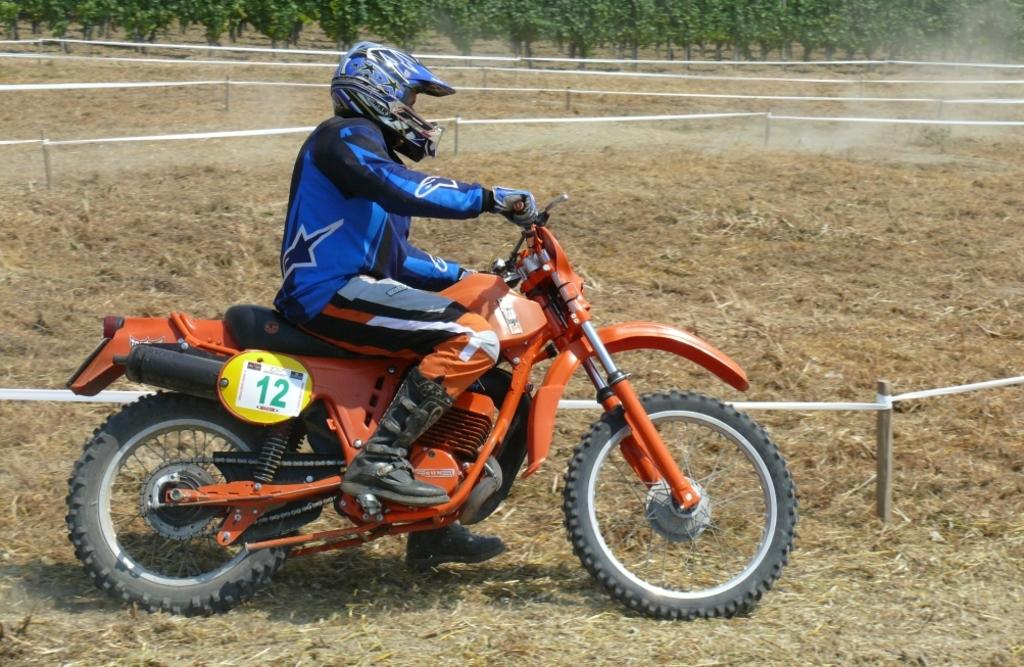What is the main subject of the image? There is a man in the image. What is the man doing in the image? The man is riding a sports bike. What color is the sports bike? The sports bike is orange in color. What is the man wearing while riding the sports bike? The man is wearing a blue dress and a helmet. What can be seen in the background of the image? There are trees visible at the top of the image. What type of ball is the man holding while riding the sports bike? There is no ball present in the image; the man is riding a sports bike and wearing a helmet. What idea does the man have while riding the sports bike? The image does not provide any information about the man's thoughts or ideas while riding the sports bike. 